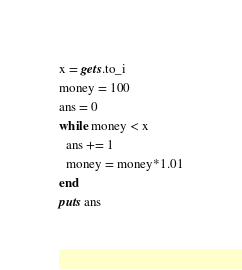Convert code to text. <code><loc_0><loc_0><loc_500><loc_500><_Ruby_>x = gets.to_i
money = 100
ans = 0
while money < x
  ans += 1
  money = money*1.01
end
puts ans</code> 